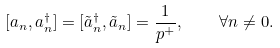Convert formula to latex. <formula><loc_0><loc_0><loc_500><loc_500>[ a _ { n } , a _ { n } ^ { \dagger } ] = [ \tilde { a } _ { n } ^ { \dagger } , \tilde { a } _ { n } ] = \frac { 1 } { p ^ { + } } , \quad \forall n \ne 0 .</formula> 